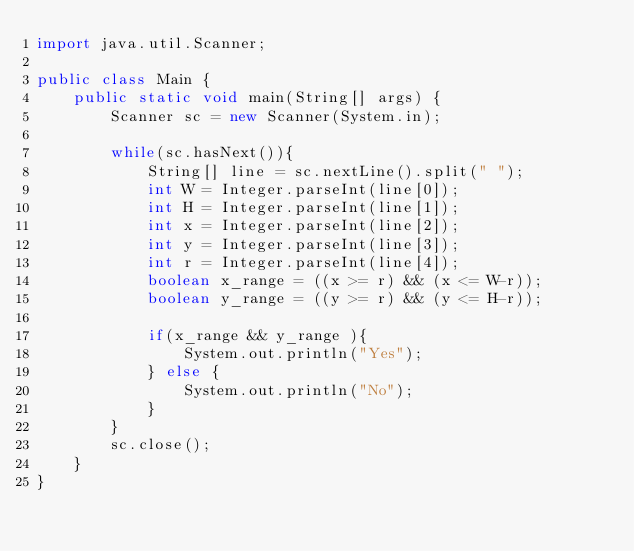<code> <loc_0><loc_0><loc_500><loc_500><_Java_>import java.util.Scanner;
 
public class Main {
    public static void main(String[] args) {
        Scanner sc = new Scanner(System.in);
 
        while(sc.hasNext()){
            String[] line = sc.nextLine().split(" ");
            int W = Integer.parseInt(line[0]);
            int H = Integer.parseInt(line[1]);
            int x = Integer.parseInt(line[2]);
            int y = Integer.parseInt(line[3]);
            int r = Integer.parseInt(line[4]);
            boolean x_range = ((x >= r) && (x <= W-r));
            boolean y_range = ((y >= r) && (y <= H-r));
 
            if(x_range && y_range ){
                System.out.println("Yes");
            } else {
                System.out.println("No");
            }
        }
        sc.close();
    }
}</code> 